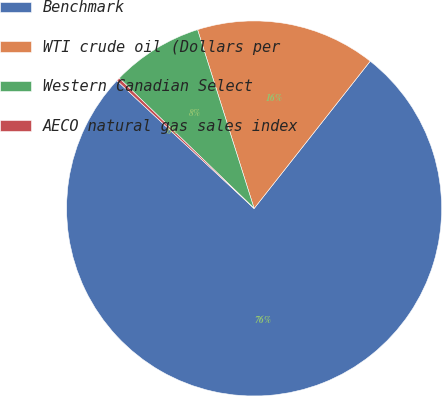Convert chart to OTSL. <chart><loc_0><loc_0><loc_500><loc_500><pie_chart><fcel>Benchmark<fcel>WTI crude oil (Dollars per<fcel>Western Canadian Select<fcel>AECO natural gas sales index<nl><fcel>76.31%<fcel>15.5%<fcel>7.9%<fcel>0.29%<nl></chart> 